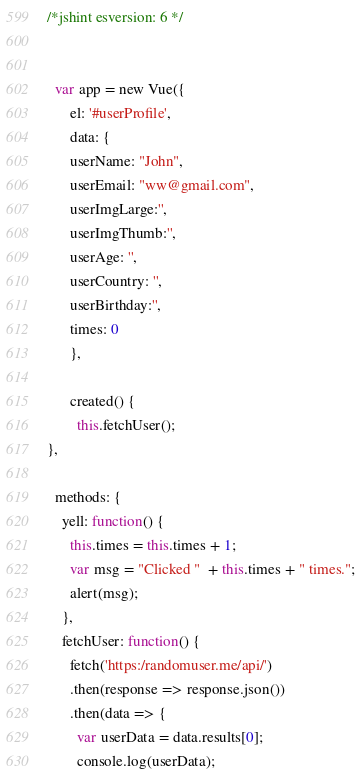<code> <loc_0><loc_0><loc_500><loc_500><_JavaScript_>/*jshint esversion: 6 */


  var app = new Vue({
      el: '#userProfile',
      data: {
      userName: "John",
      userEmail: "ww@gmail.com",
      userImgLarge:'',
      userImgThumb:'',
      userAge: '',
      userCountry: '',
      userBirthday:'',
      times: 0
      },

      created() {
        this.fetchUser();
},

  methods: {
    yell: function() {
      this.times = this.times + 1;
      var msg = "Clicked "  + this.times + " times.";
      alert(msg);
    },
    fetchUser: function() {
      fetch('https:/randomuser.me/api/')
      .then(response => response.json())
      .then(data => {
        var userData = data.results[0];
        console.log(userData);</code> 